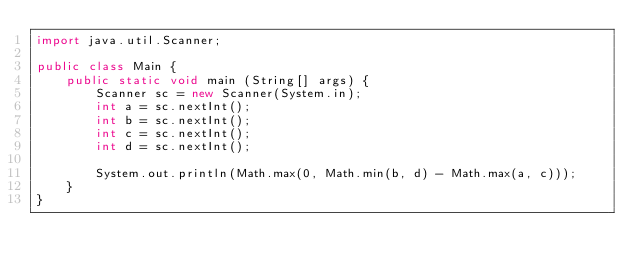Convert code to text. <code><loc_0><loc_0><loc_500><loc_500><_Java_>import java.util.Scanner;

public class Main {
    public static void main (String[] args) {
        Scanner sc = new Scanner(System.in);
        int a = sc.nextInt();
        int b = sc.nextInt();
        int c = sc.nextInt();
        int d = sc.nextInt();

        System.out.println(Math.max(0, Math.min(b, d) - Math.max(a, c)));
    }
}</code> 